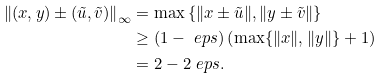Convert formula to latex. <formula><loc_0><loc_0><loc_500><loc_500>\left \| ( x , y ) \pm ( \tilde { u } , \tilde { v } ) \right \| _ { \infty } & = \max \left \{ \| x \pm \tilde { u } \| , \| y \pm \tilde { v } \| \right \} \\ & \geq ( 1 - \ e p s ) \left ( \max \{ \| x \| , \| y \| \} + 1 \right ) \\ & = 2 - 2 \ e p s .</formula> 